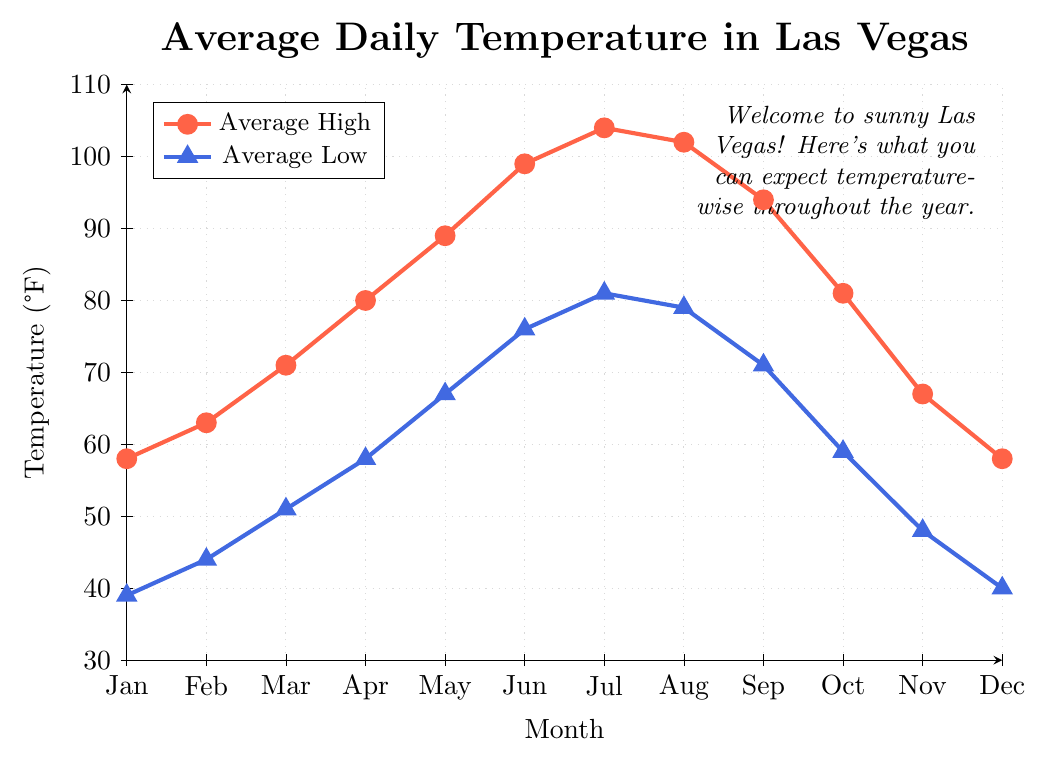What are the average high and low temperatures in July? From the figure, look at the data points for July. The average high temperature is represented by the red line with circles at the top of the chart and the average low temperature is represented by the blue line with triangles at the bottom of the chart. For July, the high is at 104°F and the low is at 81°F.
Answer: 104°F and 81°F In which month is the difference between the average high and low temperatures the greatest? To find this, calculate the difference between the high and low temperatures for each month, and identify the month with the maximum difference. 
January: 58-39=19
February: 63-44=19
March: 71-51=20
April: 80-58=22
May: 89-67=22
June: 99-76=23
July: 104-81=23
August: 102-79=23
September: 94-71=23
October: 81-59=22
November: 67-48=19
December: 58-40=18
From this, the greatest difference is in July, August, and September, all with a difference of 23°F.
Answer: July, August, and September How does the average high temperature in January compare to that in December? From the visual representation, locate the average high temperature in both January and December. Both are represented by the red line with circles and show the same temperature level of 58°F.
Answer: They are equal What is the temperature range in May (difference between high and low)? In May, view the values of the average high and low temperatures. The high is 89°F, and the low is 67°F. Calculate the range as 89 - 67.
Answer: 22°F During which months are the average low temperatures above 70°F? Identify the months where the blue line with triangles (representing low temperatures) is above the 70°F mark.
June: 76°F
July: 81°F
August: 79°F
September: 71°F
These months are June, July, August, and September.
Answer: June, July, August, and September What is the average temperature for the month of March? (Take the average of high and low) In March, the average high is 71°F, and the average low is 51°F. Average them: 
(71 + 51) / 2 = 122 / 2 = 61°F
Answer: 61°F Compare the average high temperature in October to the average low temperature in April. Which is higher? Locate the average high temperature in October, which is 81°F (red line with circles). Then, find the average low temperature in April, which is 58°F (blue line with triangles). 81°F is greater than 58°F.
Answer: The average high temperature in October is higher How many months have the average high temperature above 90°F? Refer to the red line with circles representing average high temperatures and count the months where the value is above 90°F. 
June, July, August and September
Answer: 4 months Which month shows the smallest gap between average high and low temperatures? Calculate the gaps for each month and find the smallest:
January: 58-39=19
February: 63-44=19
March: 71-51=20
April: 80-58=22
May: 89-67=22
June: 99-76=23
July: 104-81=23
August: 102-79=23
September: 94-71=23
October: 81-59=22
November: 67-48=19
December: 58-40=18
So, December has the smallest gap of 18°F.
Answer: December What is the average of the average high temperatures over the entire year? Sum the high temperatures and divide by 12:
(58 + 63 + 71 + 80 + 89 + 99 + 104 + 102 + 94 + 81 + 67 + 58) = 966 
966 / 12 = 80.5°F
Answer: 80.5°F 